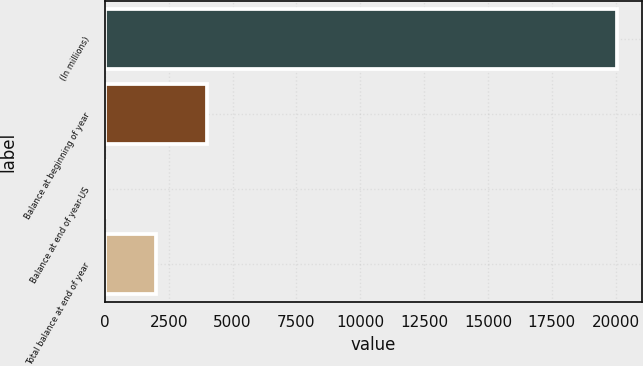Convert chart to OTSL. <chart><loc_0><loc_0><loc_500><loc_500><bar_chart><fcel>(In millions)<fcel>Balance at beginning of year<fcel>Balance at end of year-US<fcel>Total balance at end of year<nl><fcel>20041<fcel>4019.4<fcel>14<fcel>2016.7<nl></chart> 